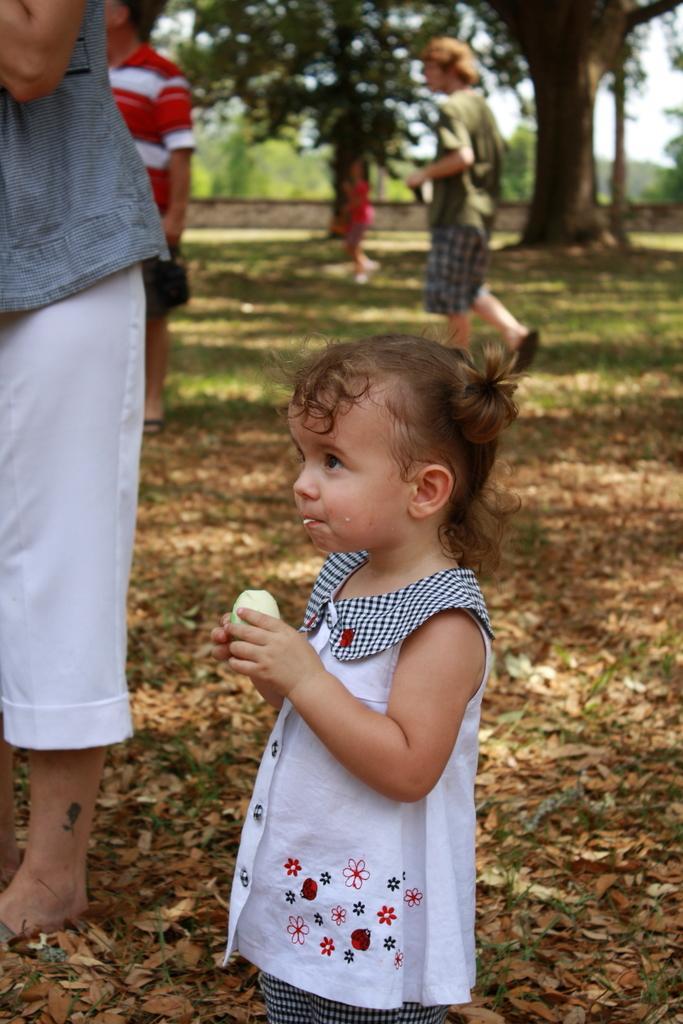Describe this image in one or two sentences. In this image in the foreground there is one baby standing and she is eating something. In the background there are some persons walking, and also i can see some trees. At the bottom there are some leaves, and grass. 